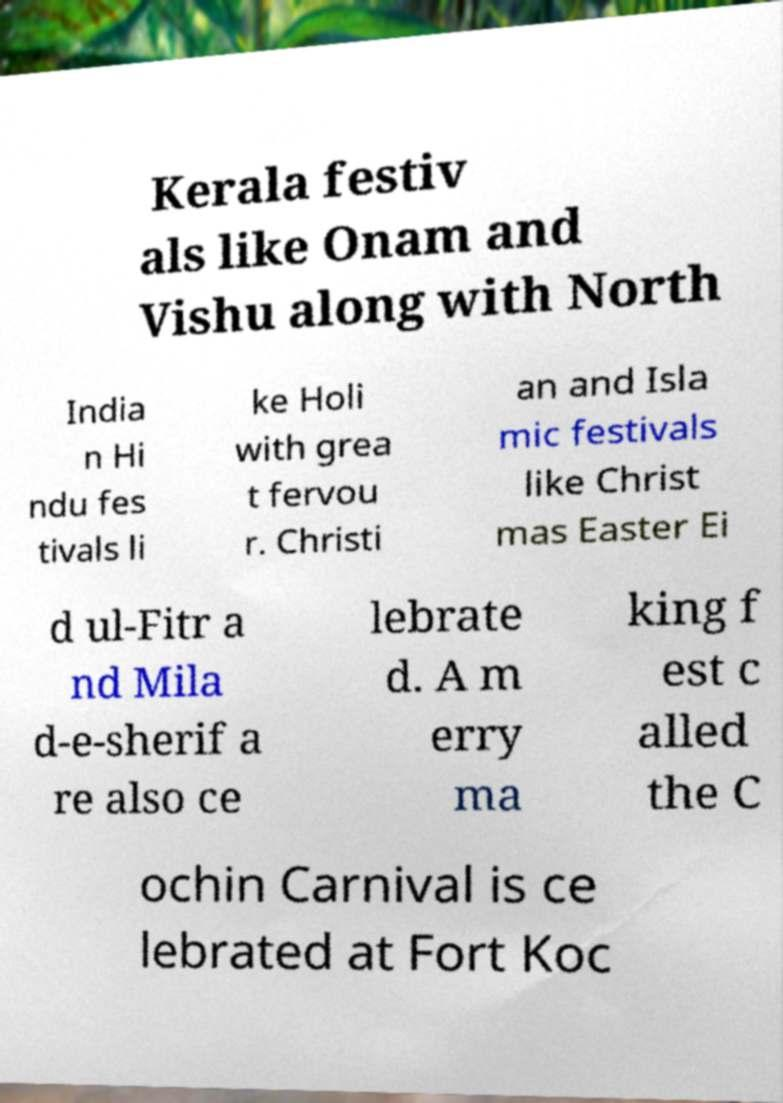There's text embedded in this image that I need extracted. Can you transcribe it verbatim? Kerala festiv als like Onam and Vishu along with North India n Hi ndu fes tivals li ke Holi with grea t fervou r. Christi an and Isla mic festivals like Christ mas Easter Ei d ul-Fitr a nd Mila d-e-sherif a re also ce lebrate d. A m erry ma king f est c alled the C ochin Carnival is ce lebrated at Fort Koc 